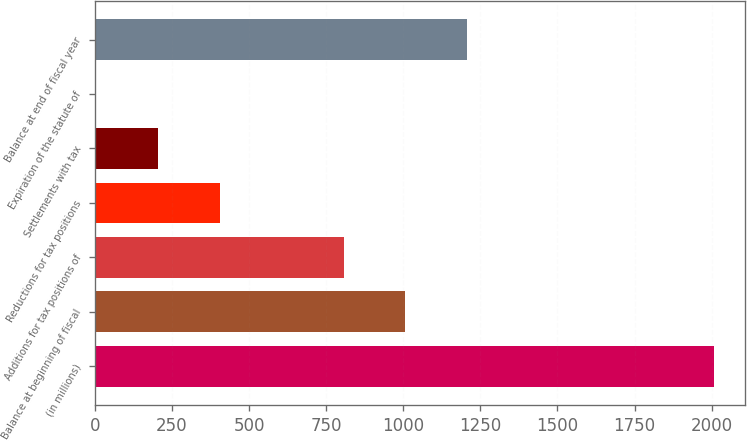Convert chart to OTSL. <chart><loc_0><loc_0><loc_500><loc_500><bar_chart><fcel>(in millions)<fcel>Balance at beginning of fiscal<fcel>Additions for tax positions of<fcel>Reductions for tax positions<fcel>Settlements with tax<fcel>Expiration of the statute of<fcel>Balance at end of fiscal year<nl><fcel>2009<fcel>1007.1<fcel>806.72<fcel>405.96<fcel>205.58<fcel>5.2<fcel>1207.48<nl></chart> 